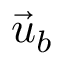Convert formula to latex. <formula><loc_0><loc_0><loc_500><loc_500>\vec { u } _ { b }</formula> 